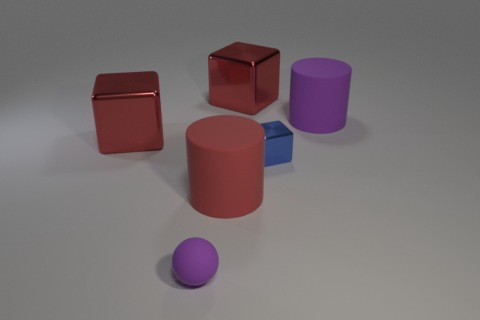Add 4 tiny yellow rubber balls. How many objects exist? 10 Subtract all blue cubes. How many cubes are left? 2 Subtract 1 blocks. How many blocks are left? 2 Subtract all yellow cylinders. Subtract all yellow blocks. How many cylinders are left? 2 Subtract all green cylinders. How many blue cubes are left? 1 Subtract all red rubber cylinders. Subtract all metal things. How many objects are left? 2 Add 5 big rubber cylinders. How many big rubber cylinders are left? 7 Add 4 big purple matte cylinders. How many big purple matte cylinders exist? 5 Subtract all purple cylinders. How many cylinders are left? 1 Subtract 0 red spheres. How many objects are left? 6 